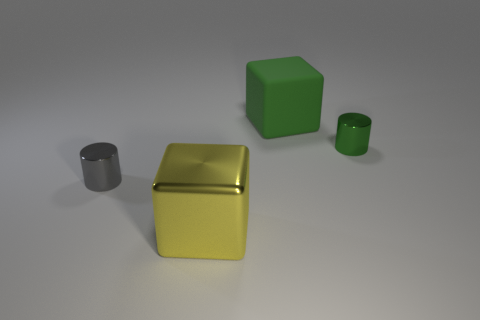There is a tiny metallic object that is right of the large yellow metal thing; is its shape the same as the gray shiny thing?
Your response must be concise. Yes. Is the number of big yellow metallic blocks left of the tiny green object greater than the number of small red objects?
Keep it short and to the point. Yes. The thing that is left of the green metallic cylinder and behind the tiny gray cylinder is made of what material?
Provide a short and direct response. Rubber. How many tiny metal cylinders are both left of the yellow shiny block and on the right side of the green cube?
Keep it short and to the point. 0. What is the green cube made of?
Ensure brevity in your answer.  Rubber. Are there the same number of green blocks that are in front of the matte cube and tiny green cylinders?
Provide a short and direct response. No. What number of gray metal objects are the same shape as the big green rubber object?
Offer a terse response. 0. Is the large yellow thing the same shape as the gray object?
Make the answer very short. No. What number of objects are either cubes that are in front of the gray thing or large brown rubber balls?
Offer a very short reply. 1. There is a green matte object behind the tiny object in front of the small shiny thing on the right side of the large yellow cube; what shape is it?
Provide a short and direct response. Cube. 